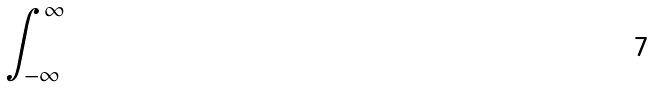Convert formula to latex. <formula><loc_0><loc_0><loc_500><loc_500>\int _ { - \infty } ^ { \infty }</formula> 